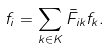Convert formula to latex. <formula><loc_0><loc_0><loc_500><loc_500>f _ { i } = \sum _ { k \in K } \bar { F } _ { i k } f _ { k } .</formula> 